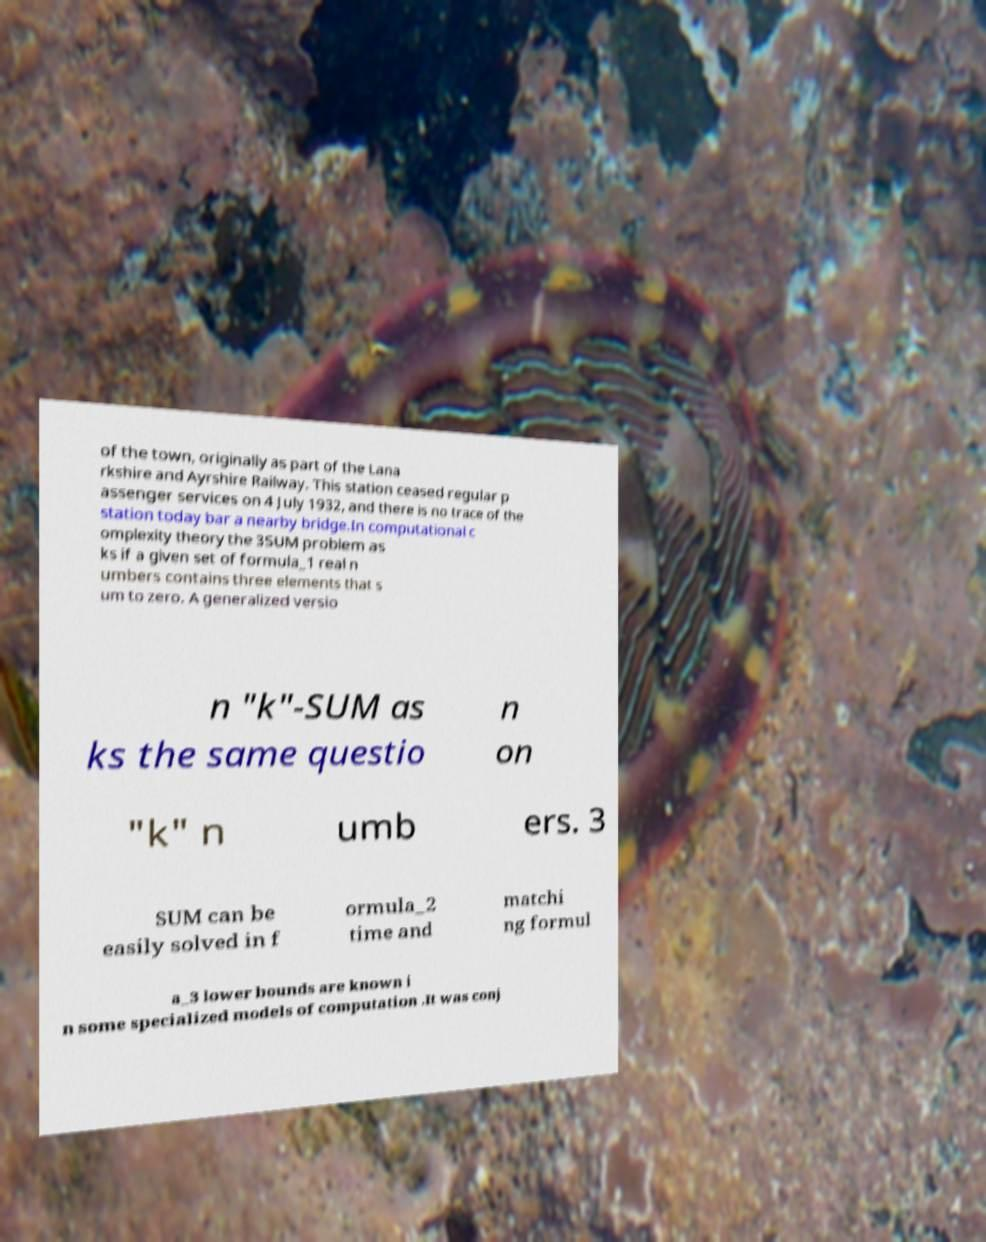Could you extract and type out the text from this image? of the town, originally as part of the Lana rkshire and Ayrshire Railway. This station ceased regular p assenger services on 4 July 1932, and there is no trace of the station today bar a nearby bridge.In computational c omplexity theory the 3SUM problem as ks if a given set of formula_1 real n umbers contains three elements that s um to zero. A generalized versio n "k"-SUM as ks the same questio n on "k" n umb ers. 3 SUM can be easily solved in f ormula_2 time and matchi ng formul a_3 lower bounds are known i n some specialized models of computation .It was conj 